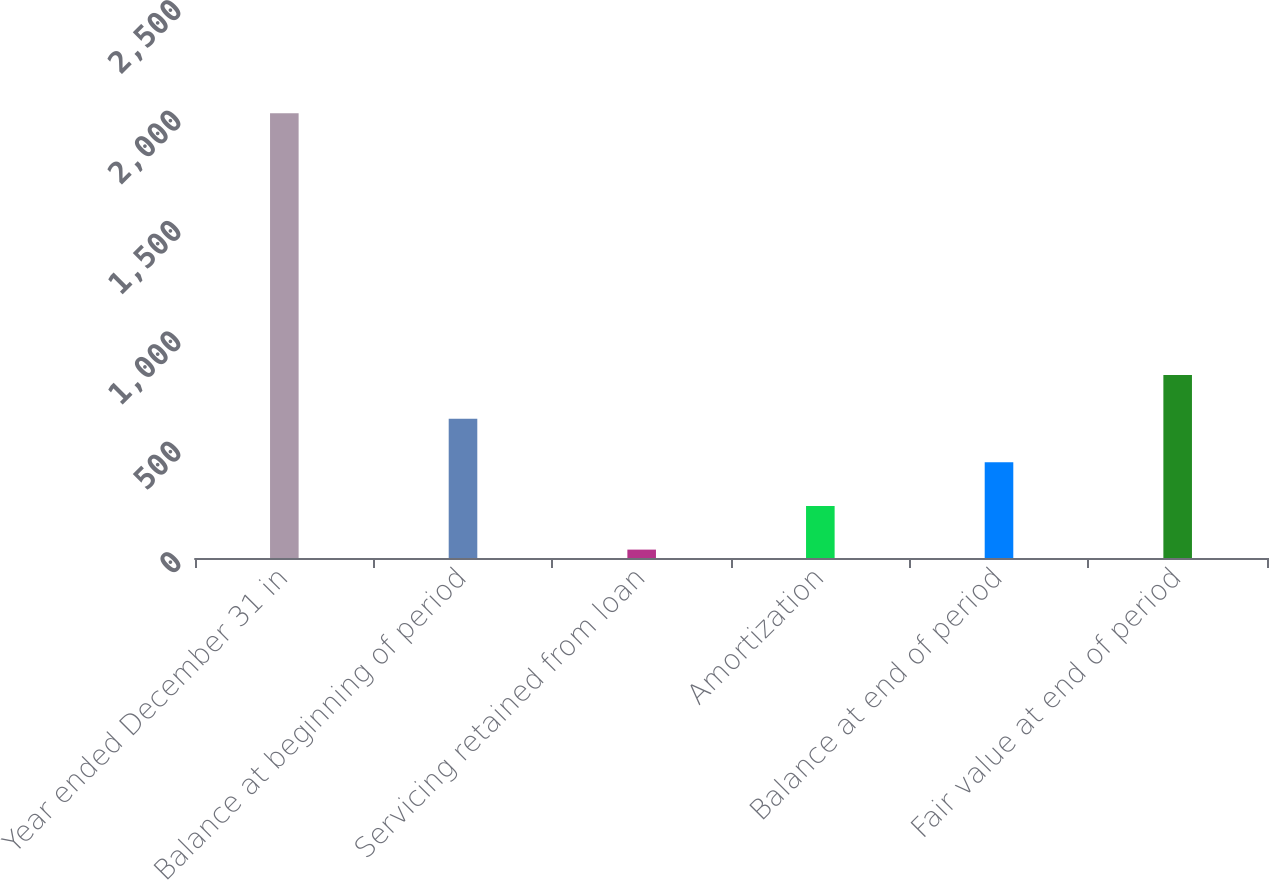Convert chart to OTSL. <chart><loc_0><loc_0><loc_500><loc_500><bar_chart><fcel>Year ended December 31 in<fcel>Balance at beginning of period<fcel>Servicing retained from loan<fcel>Amortization<fcel>Balance at end of period<fcel>Fair value at end of period<nl><fcel>2014<fcel>630.8<fcel>38<fcel>235.6<fcel>433.2<fcel>828.4<nl></chart> 